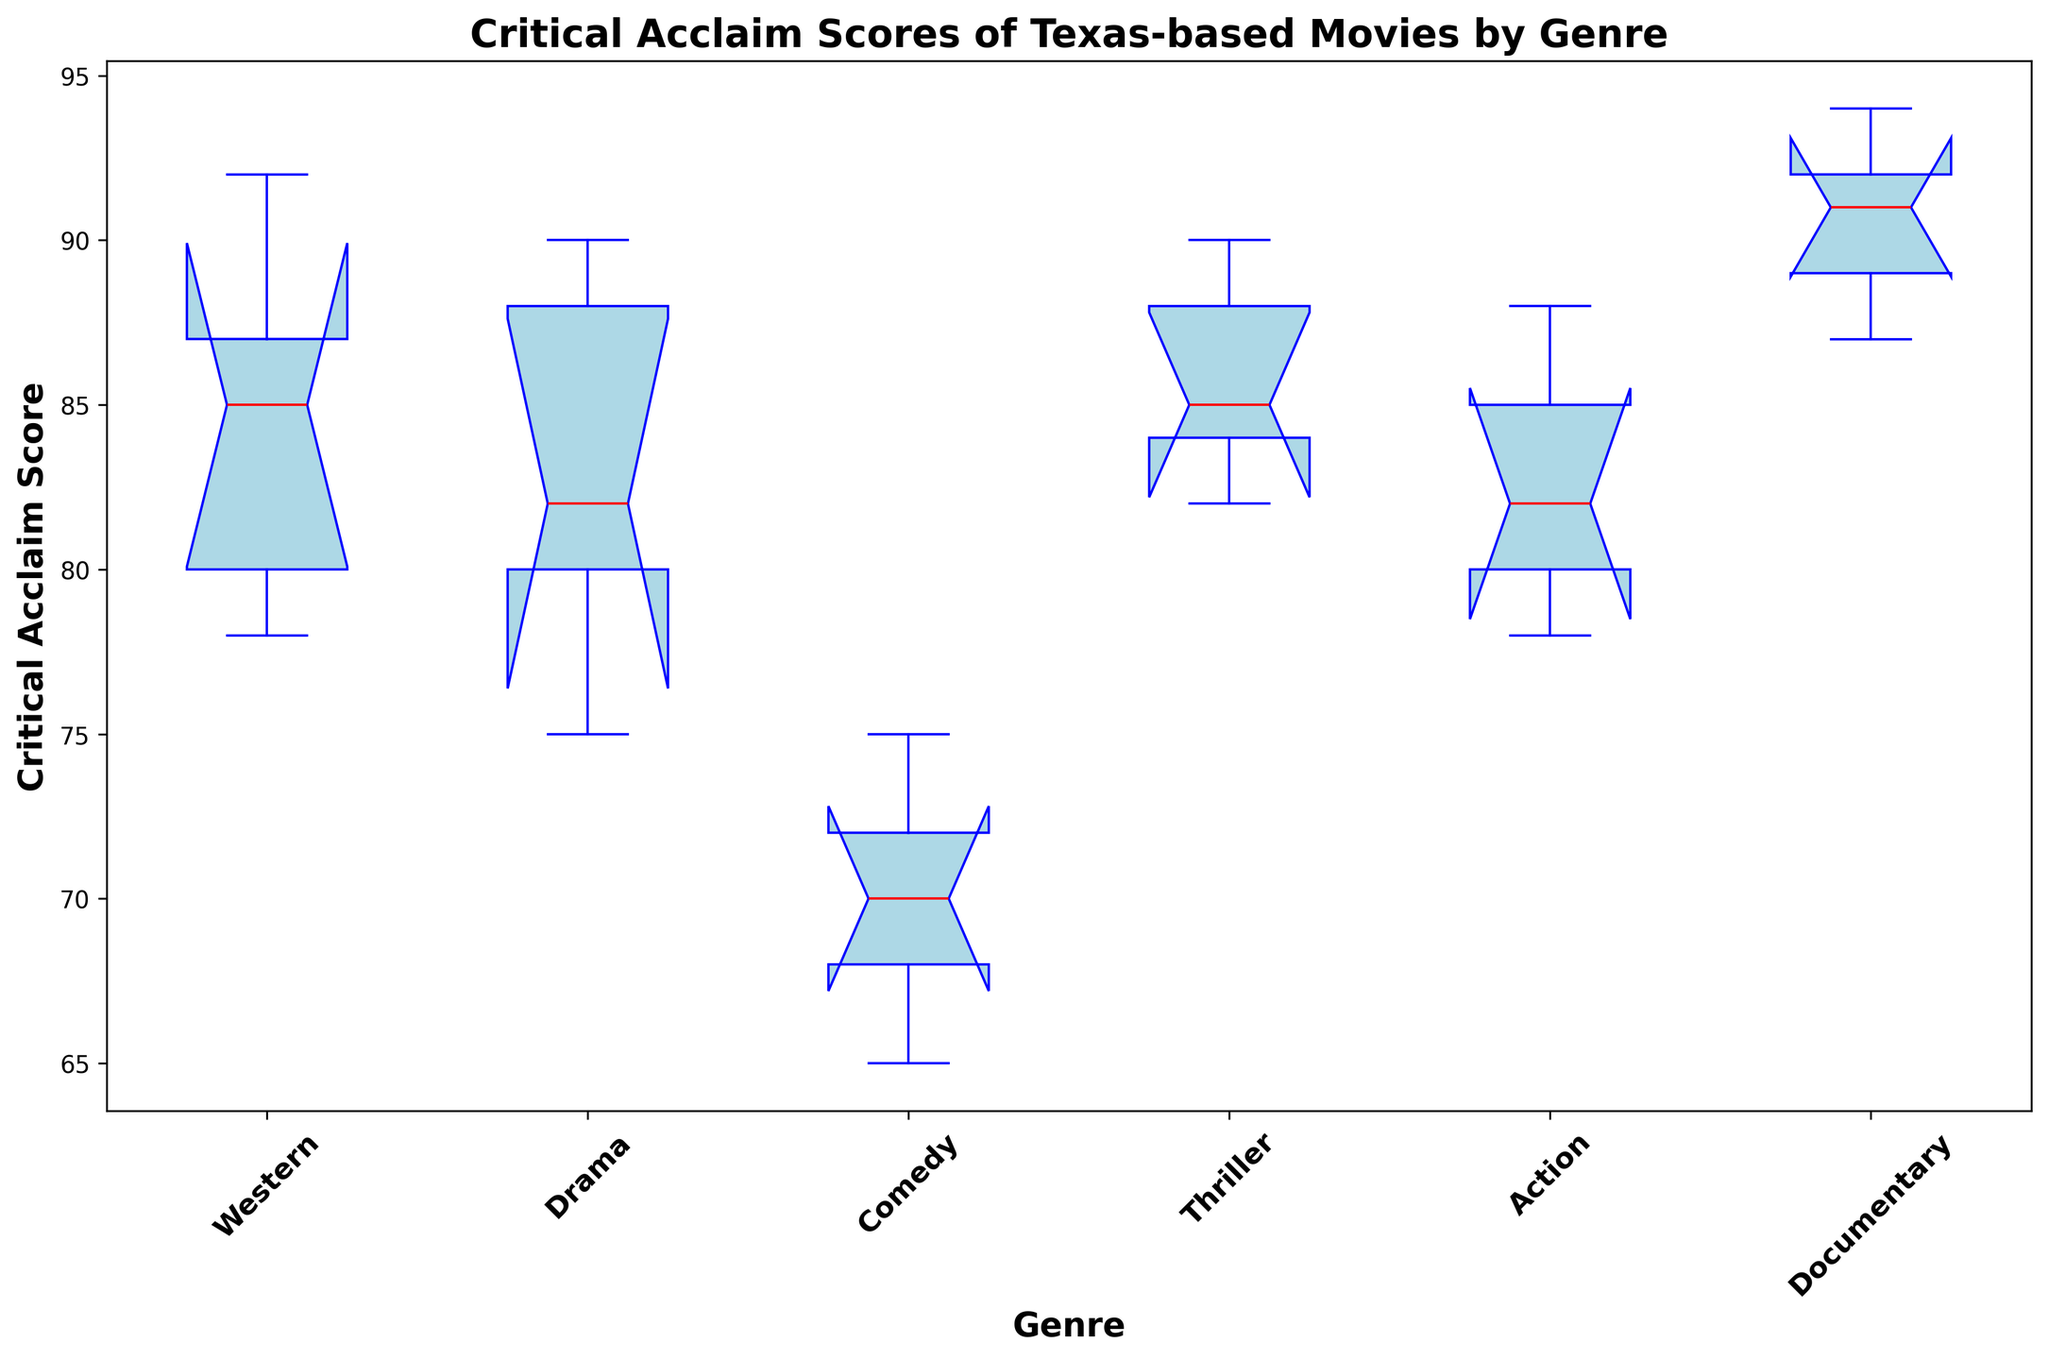what is the median score for the Drama genre? To find the median score for the Drama genre, we need to identify the middle value of the sorted Drama scores (75, 80, 82, 88, 90). The median is the third value which is 82.
Answer: 82 Which genre has the lowest median score? To identify the genre with the lowest median score, look at the median lines in the box plots for each genre. The genre with the lowest median line is Comedy.
Answer: Comedy What is the interquartile range (IQR) for the Documentary genre? The IQR is the difference between the first quartile (Q1) and the third quartile (Q3). For the Documentary genre, Q1 is 89 and Q3 is 92. Therefore, IQR is 92 - 89.
Answer: 3 Which genre has the highest maximum critical acclaim score? The "Documentary" genre has the highest maximum score, as observed in the upper whisker of the box plot.
Answer: Documentary How does the range of scores for the Western genre compare with the range for the Comedy genre? The range is the difference between the maximum and minimum scores. For Western, it is 92 - 78 = 14. For Comedy, it is 75 - 65 = 10. Western has a larger range than Comedy.
Answer: Western has a larger range Are there any genres where the median score is above 85? A visual inspection of the box plots shows that Documentary and Thriller genres have their median lines above 85.
Answer: Documentary and Thriller What is the approximate range of the interquartile range (IQR) for the Action genre? The IQR for the Action genre can be identified by looking at the spread within the box. For Action, it's from approximately 80 (Q1) to 85 (Q3), so the IQR is 85 - 80.
Answer: 5 Compare the spread of scores in the Thriller genre to that in the Drama genre. To compare the spread, look at the length of the boxes and whiskers. Thriller's whiskers and box are shorter, indicating a smaller spread compared to Drama's.
Answer: Drama has a larger spread What is the minimum score recorded for the Thriller genre, and how does it compare to the minimum score for the Action genre? The minimum score for Thriller is 82, and for Action, it is 78. Thriller's minimum score is higher.
Answer: Thriller's minimum is higher Which genre exhibits the most variation in critical acclaim scores? The genre with the largest spread from minimum to maximum, indicated by the length of the box plot whiskers. Western shows the most variation.
Answer: Western 